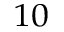<formula> <loc_0><loc_0><loc_500><loc_500>^ { 1 0 }</formula> 